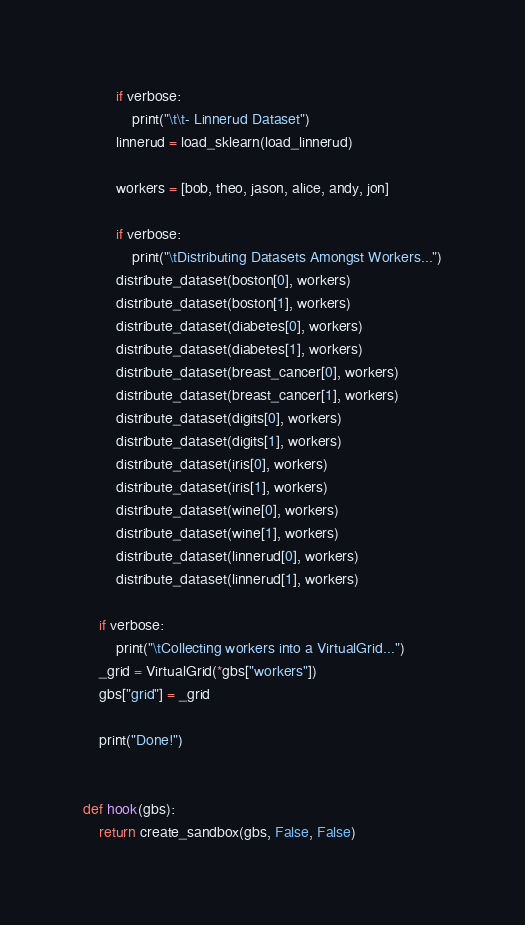Convert code to text. <code><loc_0><loc_0><loc_500><loc_500><_Python_>        if verbose:
            print("\t\t- Linnerud Dataset")
        linnerud = load_sklearn(load_linnerud)

        workers = [bob, theo, jason, alice, andy, jon]

        if verbose:
            print("\tDistributing Datasets Amongst Workers...")
        distribute_dataset(boston[0], workers)
        distribute_dataset(boston[1], workers)
        distribute_dataset(diabetes[0], workers)
        distribute_dataset(diabetes[1], workers)
        distribute_dataset(breast_cancer[0], workers)
        distribute_dataset(breast_cancer[1], workers)
        distribute_dataset(digits[0], workers)
        distribute_dataset(digits[1], workers)
        distribute_dataset(iris[0], workers)
        distribute_dataset(iris[1], workers)
        distribute_dataset(wine[0], workers)
        distribute_dataset(wine[1], workers)
        distribute_dataset(linnerud[0], workers)
        distribute_dataset(linnerud[1], workers)

    if verbose:
        print("\tCollecting workers into a VirtualGrid...")
    _grid = VirtualGrid(*gbs["workers"])
    gbs["grid"] = _grid

    print("Done!")


def hook(gbs):
    return create_sandbox(gbs, False, False)
</code> 